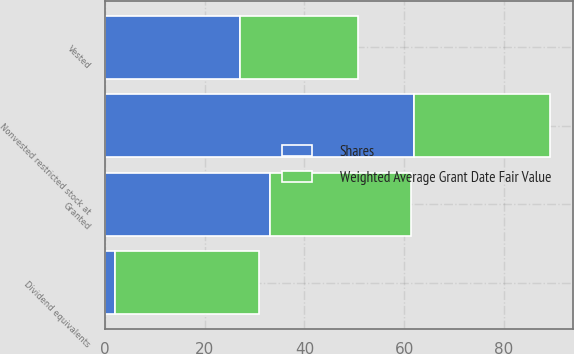Convert chart. <chart><loc_0><loc_0><loc_500><loc_500><stacked_bar_chart><ecel><fcel>Nonvested restricted stock at<fcel>Granted<fcel>Vested<fcel>Dividend equivalents<nl><fcel>Shares<fcel>62<fcel>33<fcel>27<fcel>2<nl><fcel>Weighted Average Grant Date Fair Value<fcel>27.33<fcel>28.3<fcel>23.65<fcel>28.88<nl></chart> 